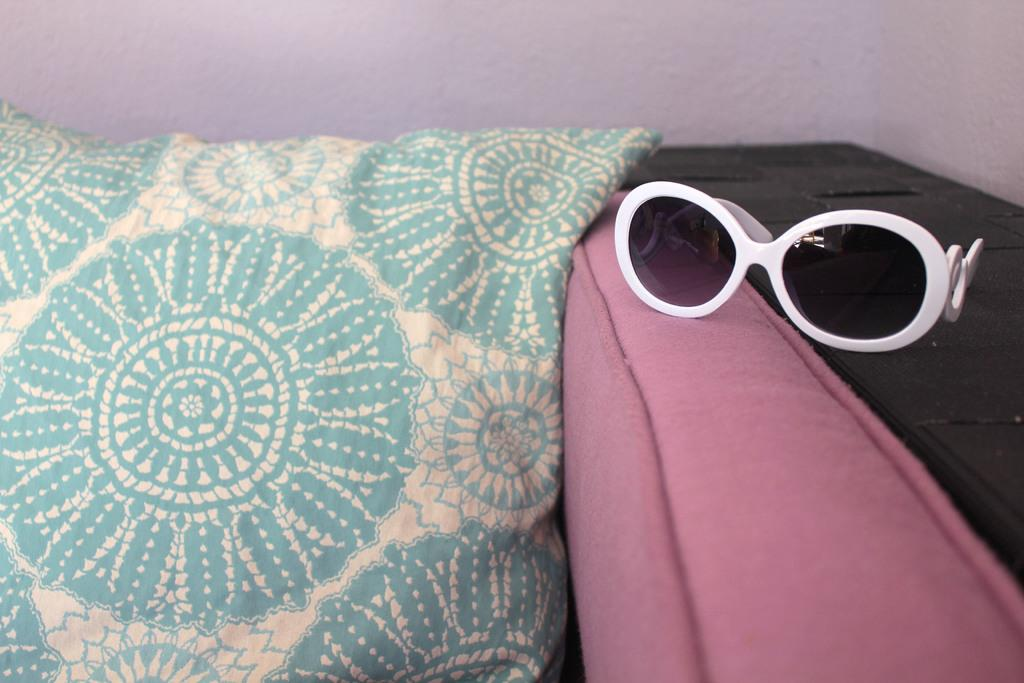What is placed on the sofa in the image? There is a pillow on a pink color sofa in the image. What object can be seen on the right side of the image? There are goggles on the right side of the image. What can be seen in the background of the image? There is a wall visible in the background of the image. Where is the lift located in the image? There is no lift present in the image. 